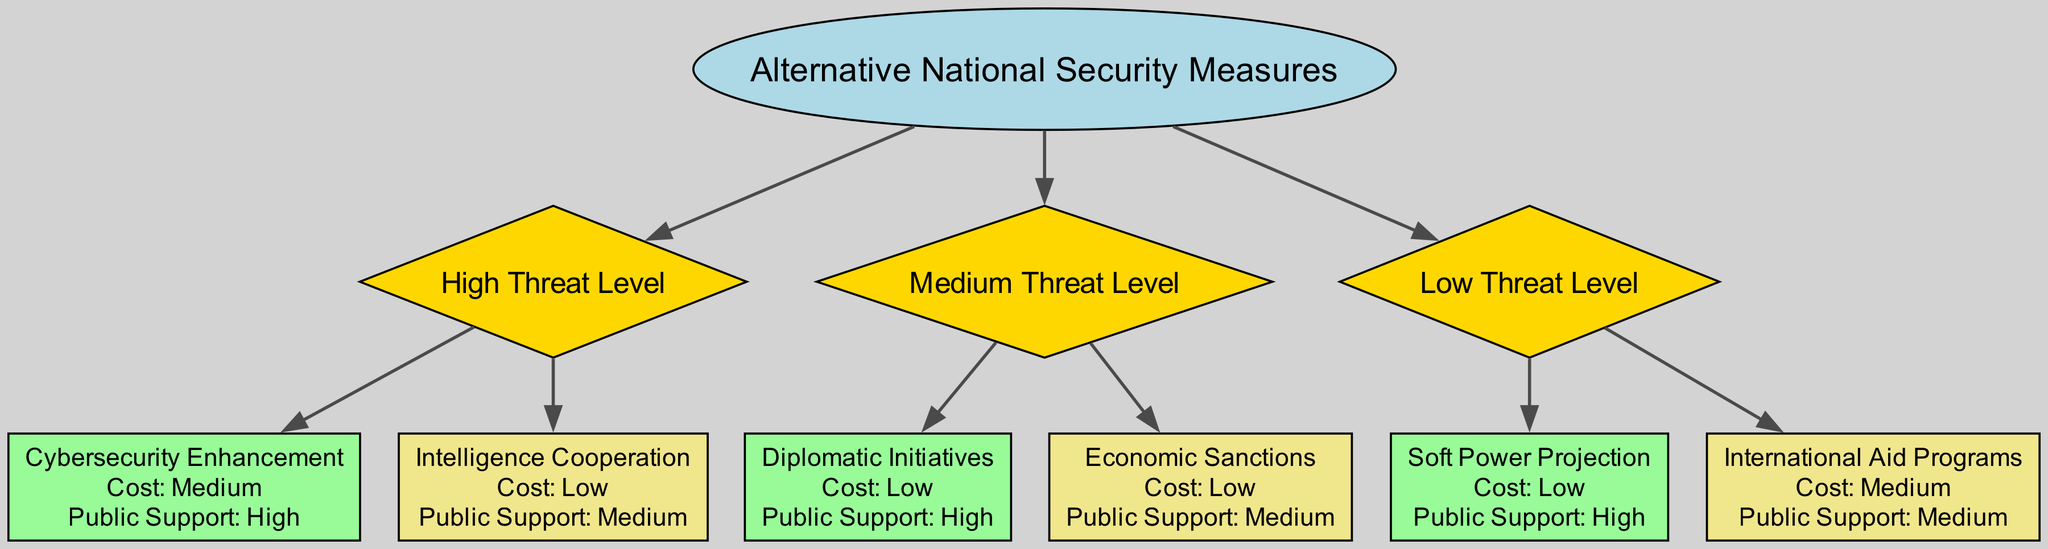What is the root node of the diagram? The root node, which represents the highest level of the decision tree, is labeled as "Alternative National Security Measures."
Answer: Alternative National Security Measures How many branches are under the "High Threat Level"? There are two branches under the "High Threat Level": "Cybersecurity Enhancement" and "Intelligence Cooperation."
Answer: 2 Which measure has the highest public support in the "Medium Threat Level"? The measure with the highest public support in the "Medium Threat Level" is "Diplomatic Initiatives," which has high public support.
Answer: Diplomatic Initiatives What is the cost associated with "Soft Power Projection"? "Soft Power Projection" is associated with a low cost, as indicated in the attributes listed for that node.
Answer: Low If the threat level is low, which measures can be considered? Under low threat level, the options to consider are "Soft Power Projection" and "International Aid Programs."
Answer: Soft Power Projection, International Aid Programs Which alternative measure has a medium cost and high public support? Analyzing the nodes in the diagram, it appears that there is no measure listed with a medium cost and high public support simultaneously.
Answer: None Which alternative has low cost and medium public support under "High Threat Level"? Moving through the "High Threat Level" branch, the measure that matches low cost and medium public support is "Intelligence Cooperation."
Answer: Intelligence Cooperation What is the total number of measures listed in the diagram? By counting all the measures from each threat level branch—2 from high, 2 from medium, and 2 from low—the total comes to 6 measures listed in the diagram.
Answer: 6 In the diagram, what type of node is "Intelligence Cooperation"? "Intelligence Cooperation" is classified as a box-shaped node, which indicates that it is a terminal node in the decision tree hierarchy.
Answer: Box 